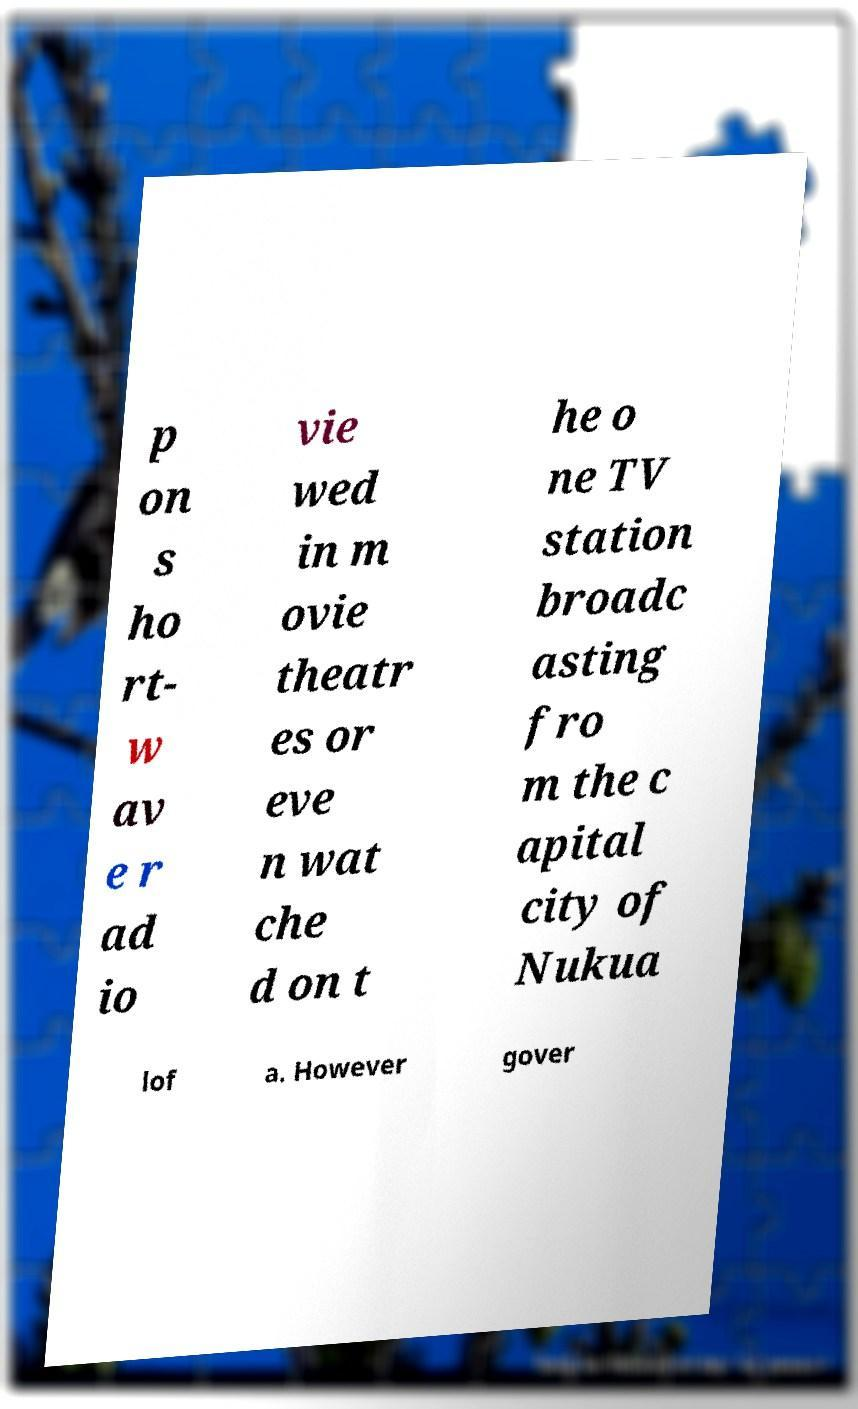Could you extract and type out the text from this image? p on s ho rt- w av e r ad io vie wed in m ovie theatr es or eve n wat che d on t he o ne TV station broadc asting fro m the c apital city of Nukua lof a. However gover 